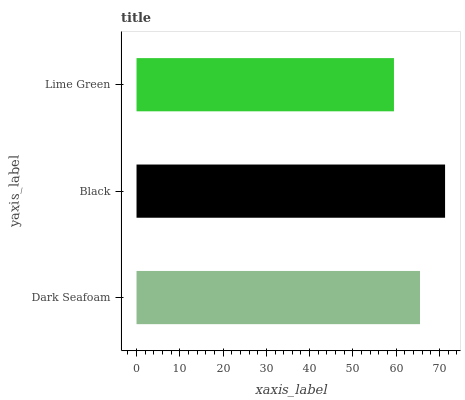Is Lime Green the minimum?
Answer yes or no. Yes. Is Black the maximum?
Answer yes or no. Yes. Is Black the minimum?
Answer yes or no. No. Is Lime Green the maximum?
Answer yes or no. No. Is Black greater than Lime Green?
Answer yes or no. Yes. Is Lime Green less than Black?
Answer yes or no. Yes. Is Lime Green greater than Black?
Answer yes or no. No. Is Black less than Lime Green?
Answer yes or no. No. Is Dark Seafoam the high median?
Answer yes or no. Yes. Is Dark Seafoam the low median?
Answer yes or no. Yes. Is Black the high median?
Answer yes or no. No. Is Lime Green the low median?
Answer yes or no. No. 